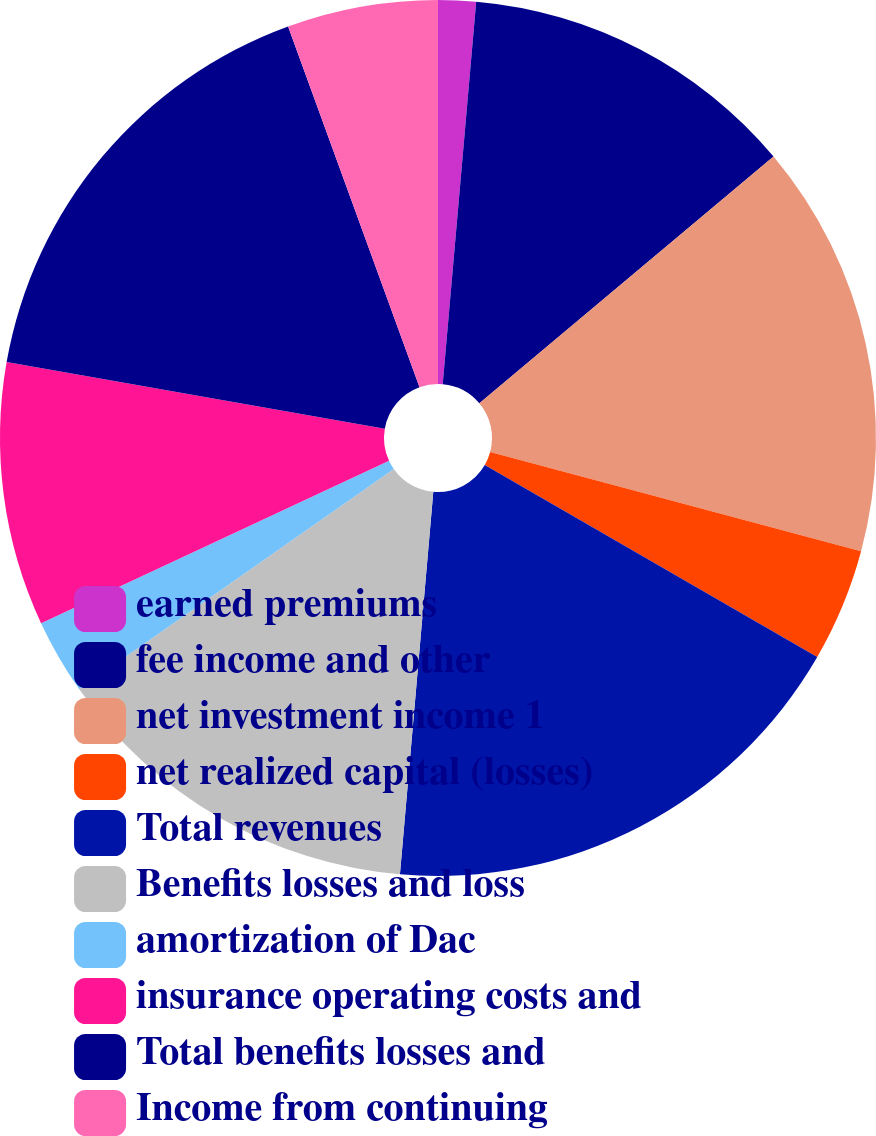<chart> <loc_0><loc_0><loc_500><loc_500><pie_chart><fcel>earned premiums<fcel>fee income and other<fcel>net investment income 1<fcel>net realized capital (losses)<fcel>Total revenues<fcel>Benefits losses and loss<fcel>amortization of Dac<fcel>insurance operating costs and<fcel>Total benefits losses and<fcel>Income from continuing<nl><fcel>1.39%<fcel>12.5%<fcel>15.28%<fcel>4.17%<fcel>18.05%<fcel>13.89%<fcel>2.78%<fcel>9.72%<fcel>16.67%<fcel>5.56%<nl></chart> 